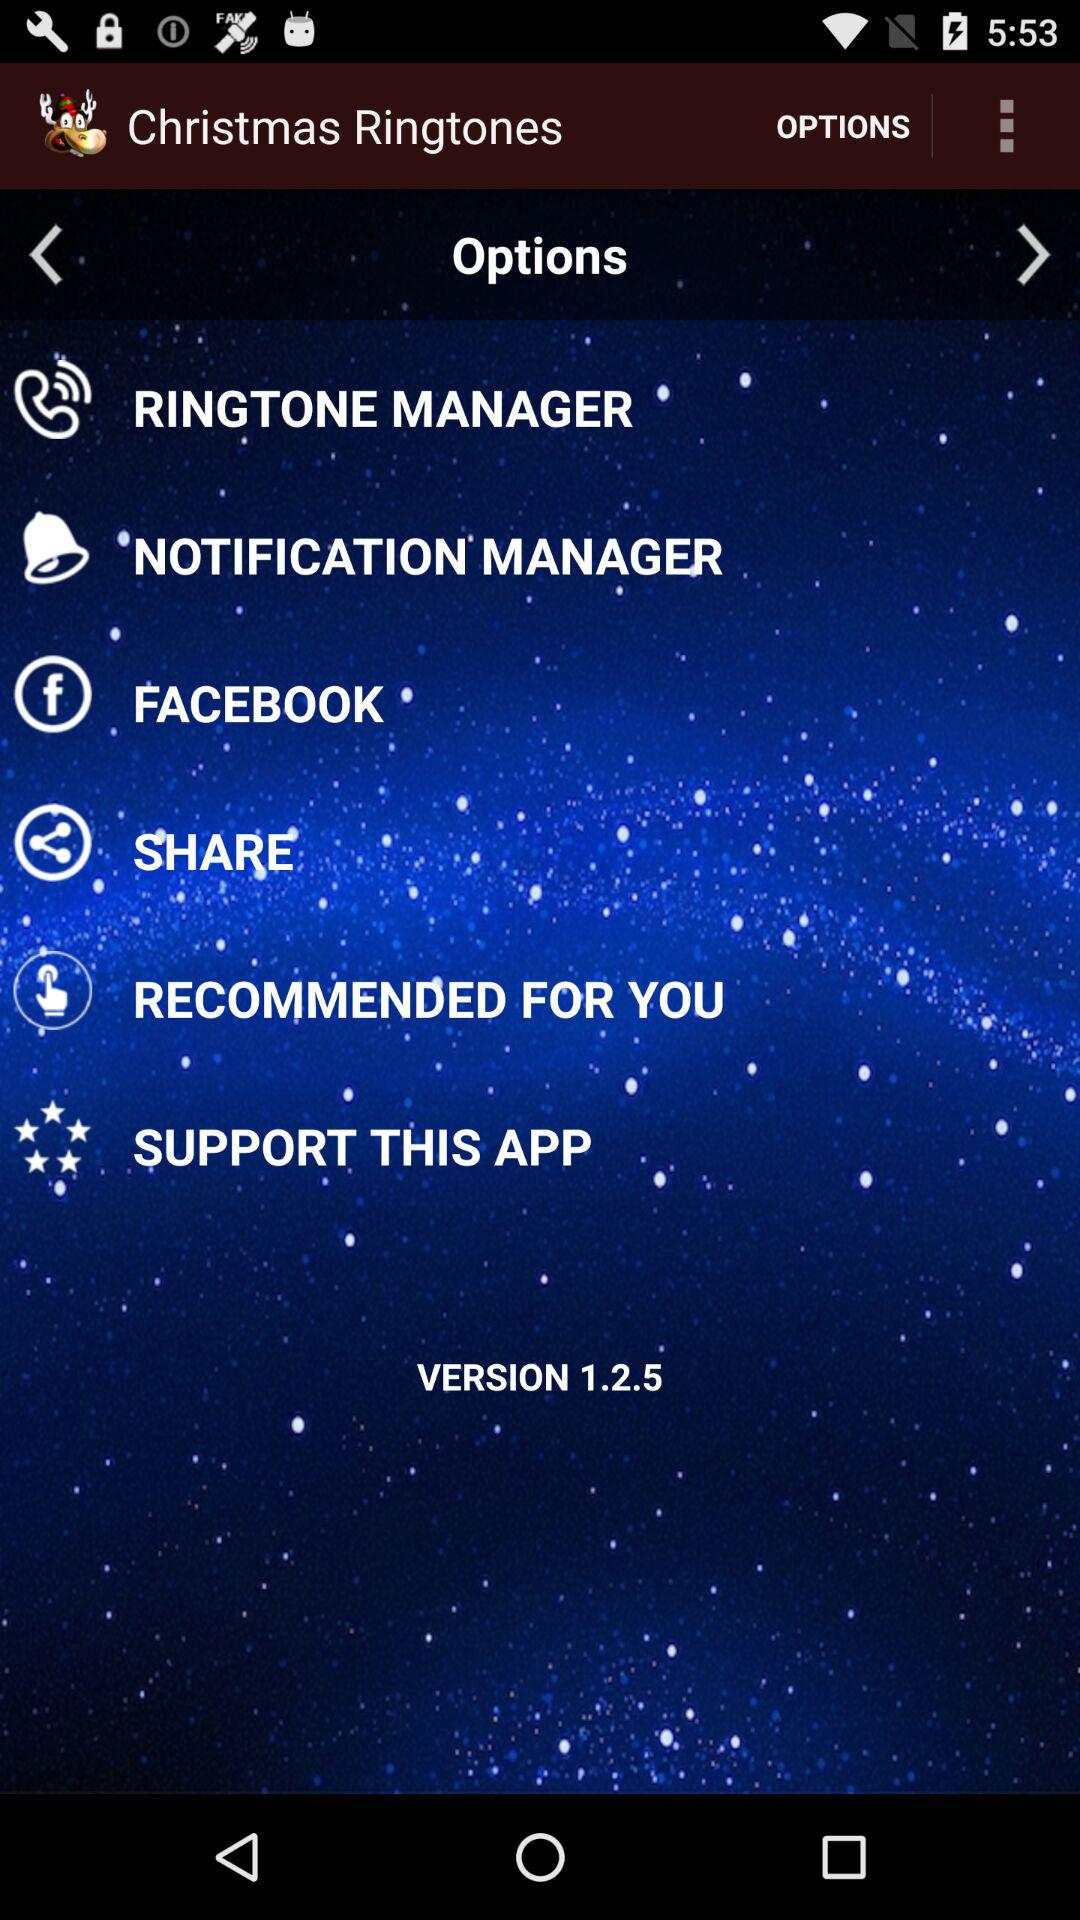What is the version? The version is 1.2.5. 